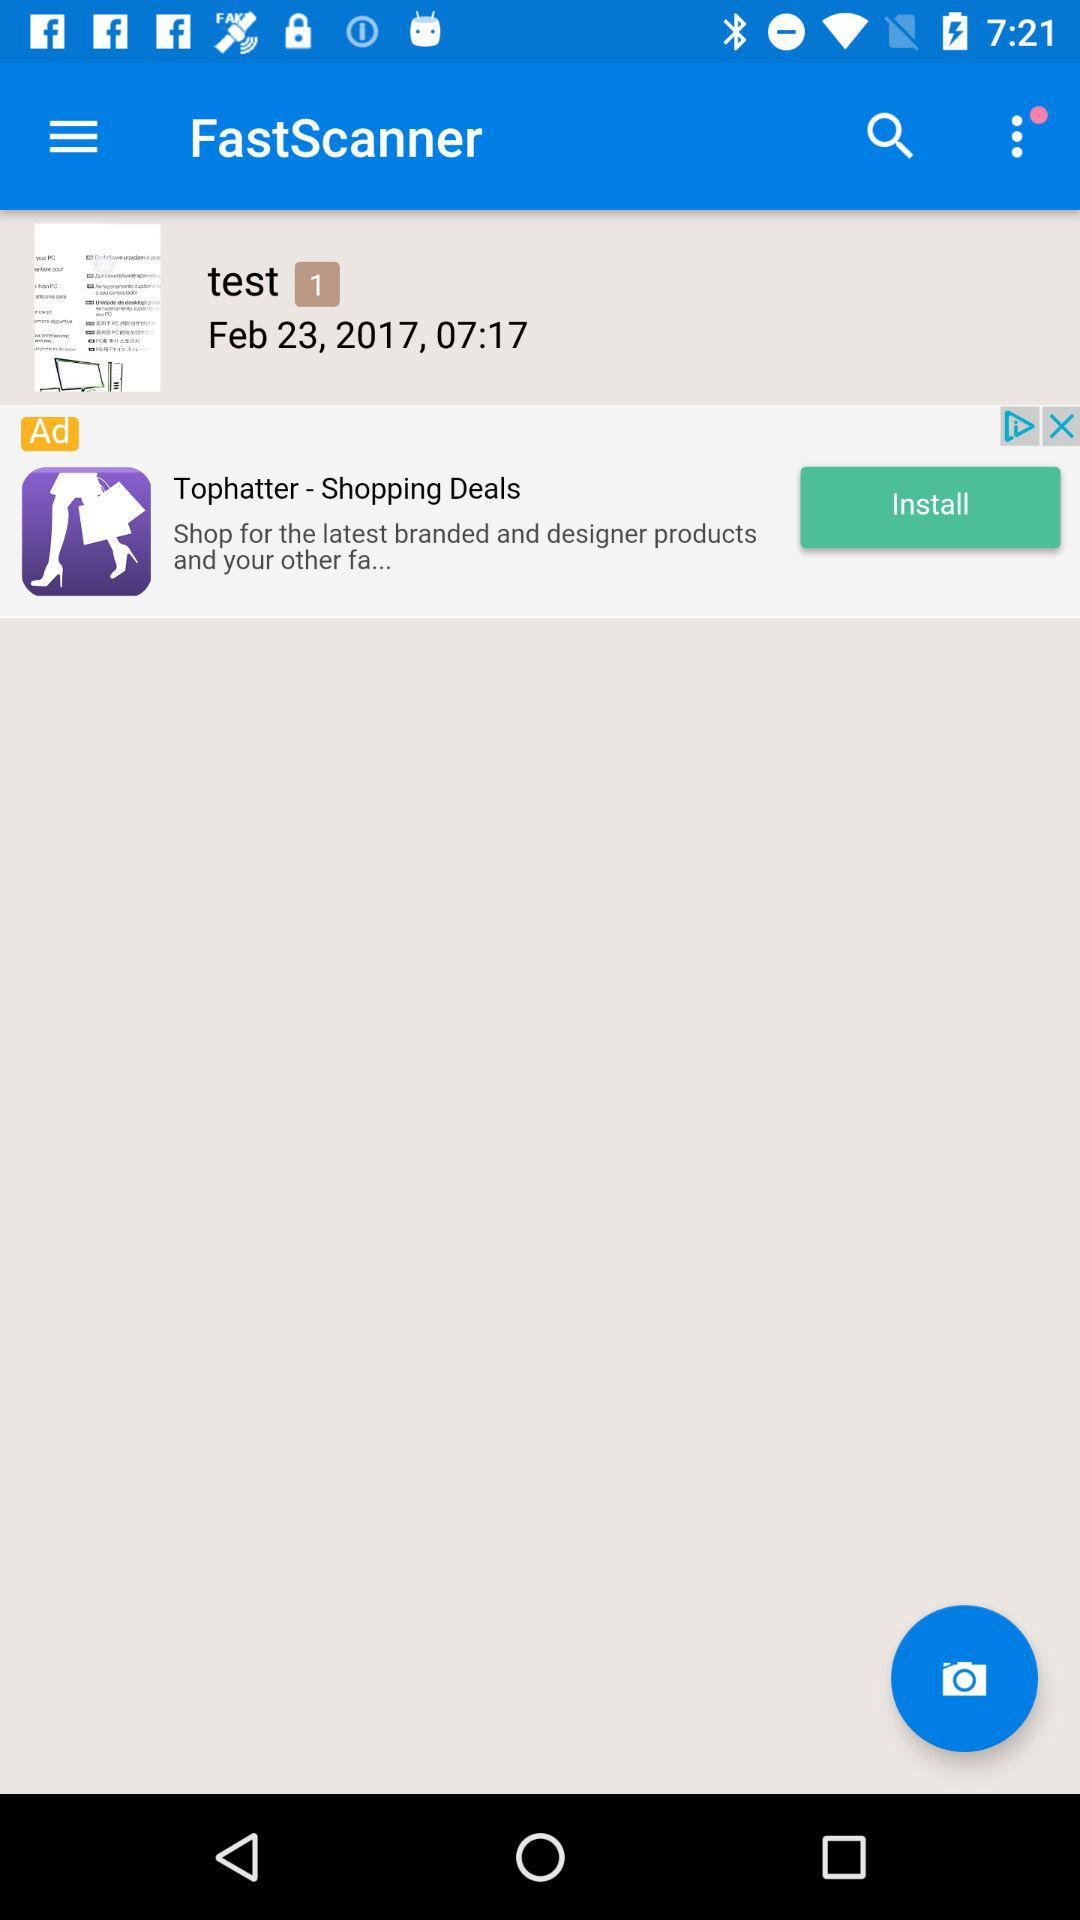What test number is it? It is test number 1. 